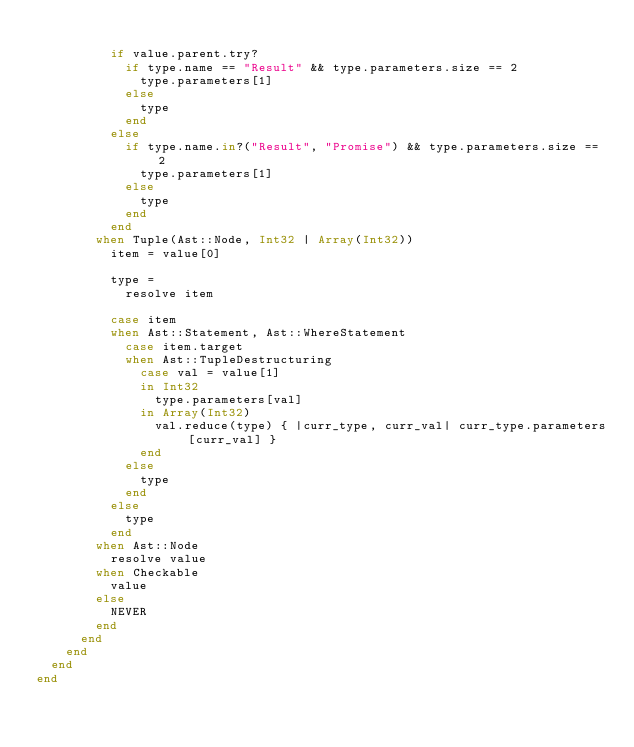Convert code to text. <code><loc_0><loc_0><loc_500><loc_500><_Crystal_>
          if value.parent.try?
            if type.name == "Result" && type.parameters.size == 2
              type.parameters[1]
            else
              type
            end
          else
            if type.name.in?("Result", "Promise") && type.parameters.size == 2
              type.parameters[1]
            else
              type
            end
          end
        when Tuple(Ast::Node, Int32 | Array(Int32))
          item = value[0]

          type =
            resolve item

          case item
          when Ast::Statement, Ast::WhereStatement
            case item.target
            when Ast::TupleDestructuring
              case val = value[1]
              in Int32
                type.parameters[val]
              in Array(Int32)
                val.reduce(type) { |curr_type, curr_val| curr_type.parameters[curr_val] }
              end
            else
              type
            end
          else
            type
          end
        when Ast::Node
          resolve value
        when Checkable
          value
        else
          NEVER
        end
      end
    end
  end
end
</code> 